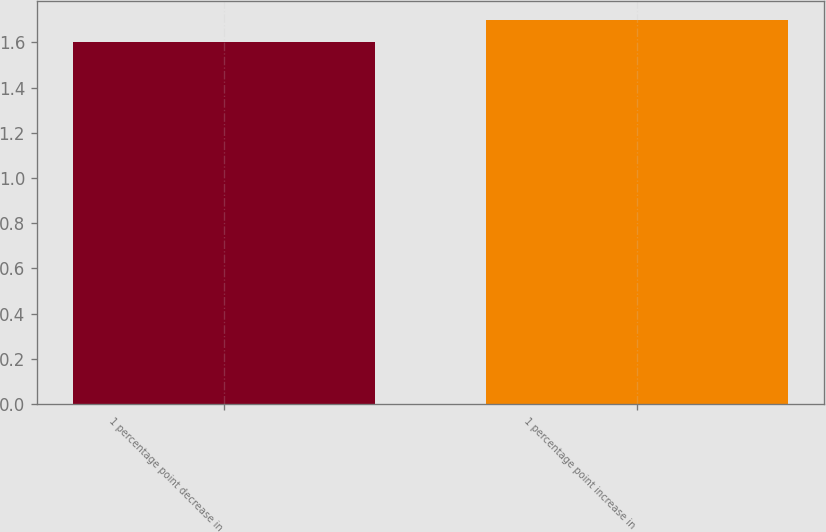<chart> <loc_0><loc_0><loc_500><loc_500><bar_chart><fcel>1 percentage point decrease in<fcel>1 percentage point increase in<nl><fcel>1.6<fcel>1.7<nl></chart> 